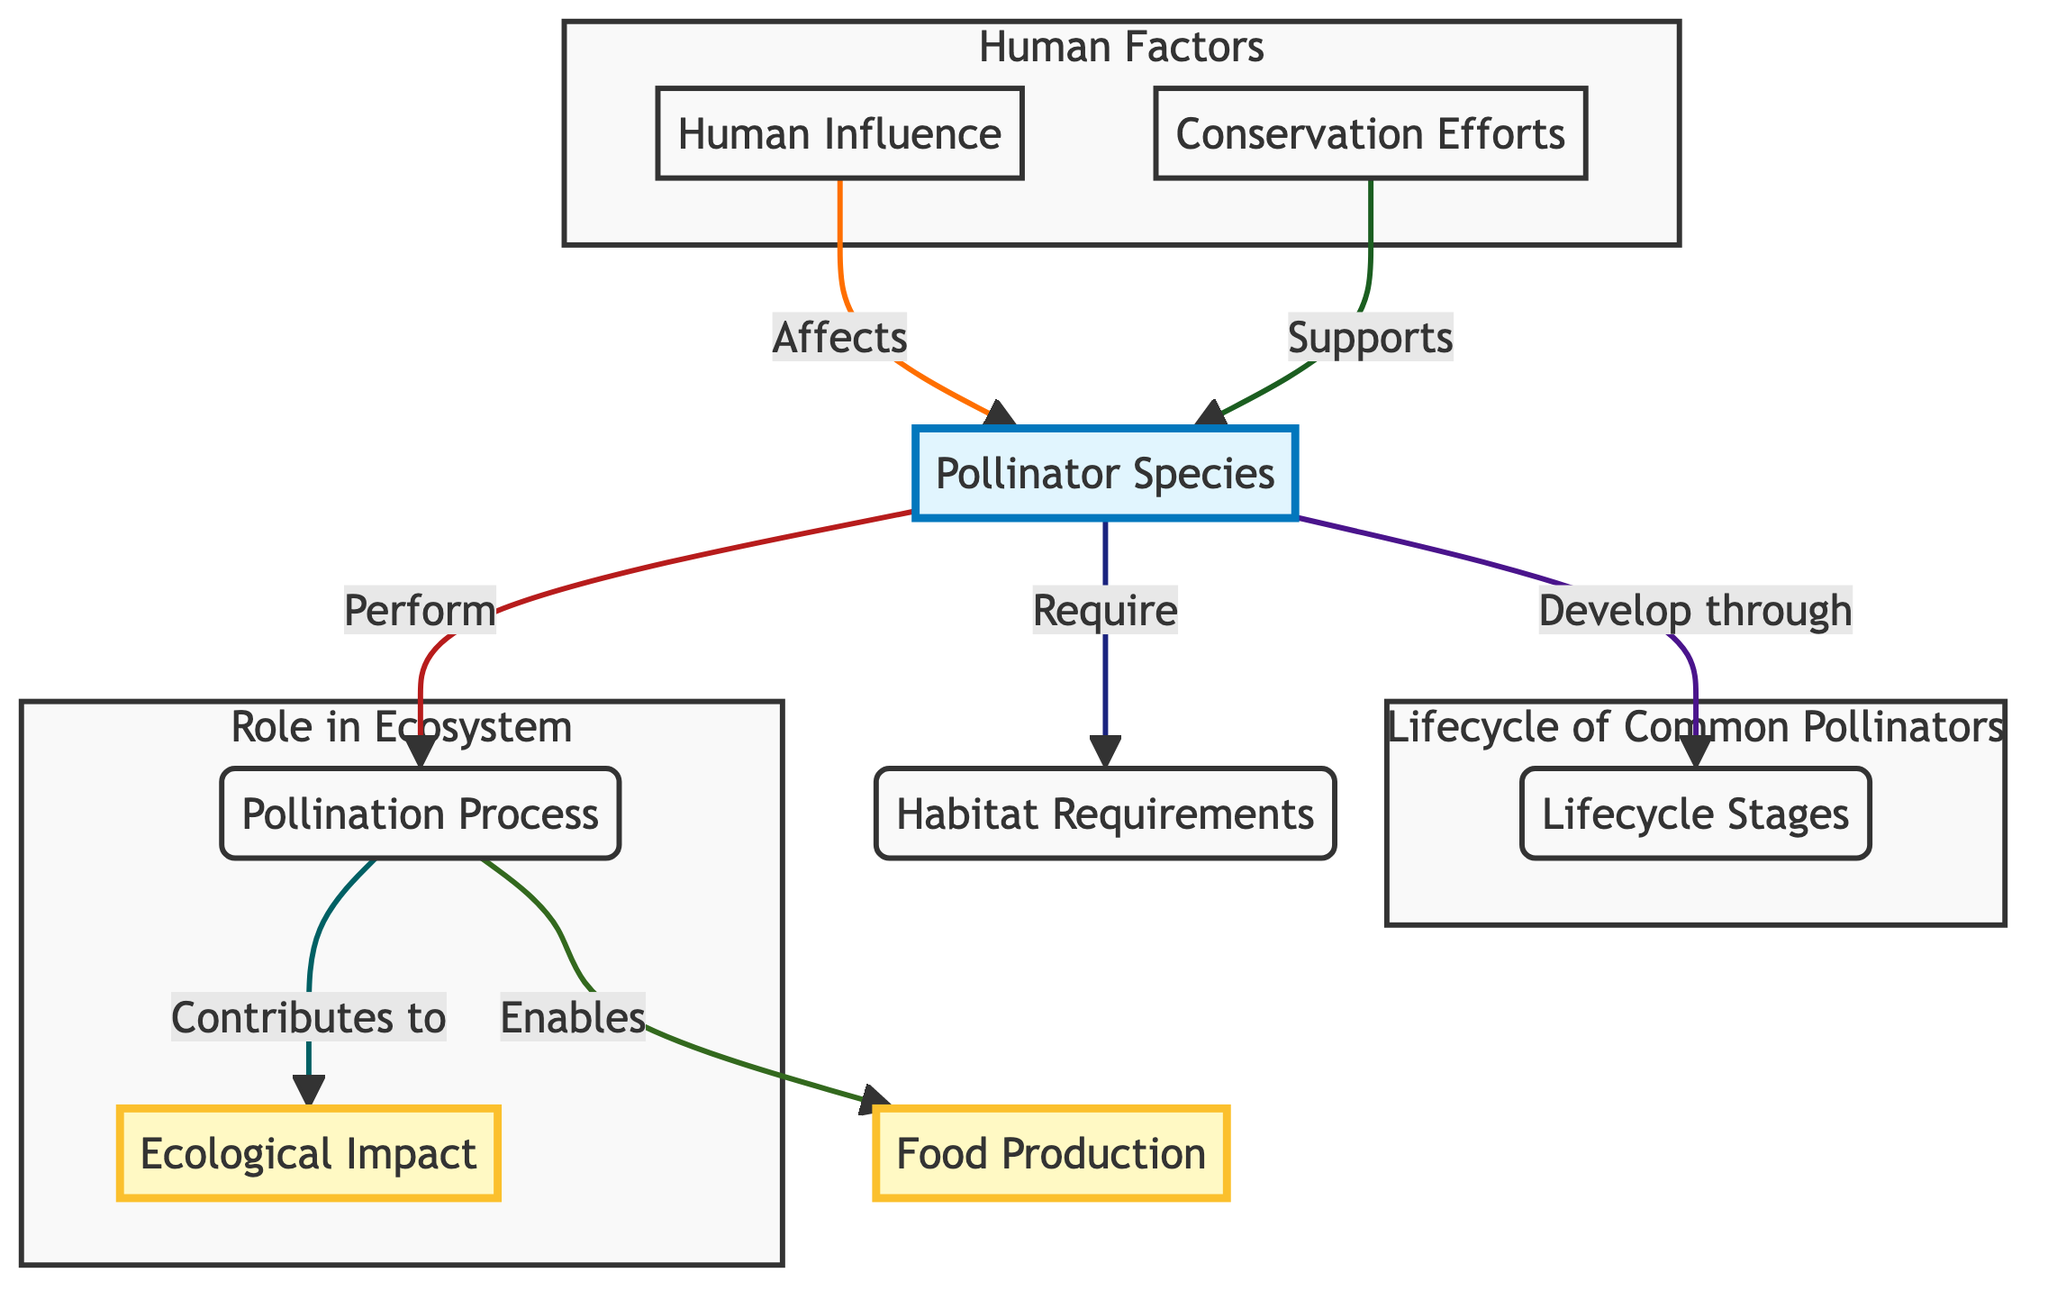What are some common pollinator species listed in the diagram? The diagram lists bees, butterflies, birds, and bats as common pollinator species.
Answer: bees, butterflies, birds, bats What are the lifecycle stages of pollinators? The lifecycle stages include egg, larva, pupa, and adult for insects; nest and fledging for birds.
Answer: egg, larva, pupa, adult, nest, fledging What does the pollination process enable? The pollination process enables food production by transferring pollen from anther to stigma, which is essential for fertilization.
Answer: Food Production How many main components are in the "Human Factors" subgraph? The "Human Factors" subgraph contains two main components: Human Influence and Conservation Efforts.
Answer: 2 What impact does pollination contribute to? Pollination contributes to ecological impact by enhancing biodiversity and ecosystem health.
Answer: Ecological Impact How does the diagram show the relationship between human influence and pollinators? The diagram shows that human influence negatively affects pollinators, indicating factors such as pesticides, habitat loss, and climate change.
Answer: Affects What supports the common pollinator species according to the diagram? Conservation efforts support common pollinator species by creating gardens, reducing pesticide use, and protecting habitats.
Answer: Conservation Efforts What is the ecological impact of pollination related to? The ecological impact of pollination is related to enhancing biodiversity and overall ecosystem health.
Answer: Enhances biodiversity What is the primary role of pollinators in food production? The primary role is to facilitate the transfer of pollen, which is necessary for the fertilization of plants that produce fruits, vegetables, and nuts.
Answer: Fertilization 